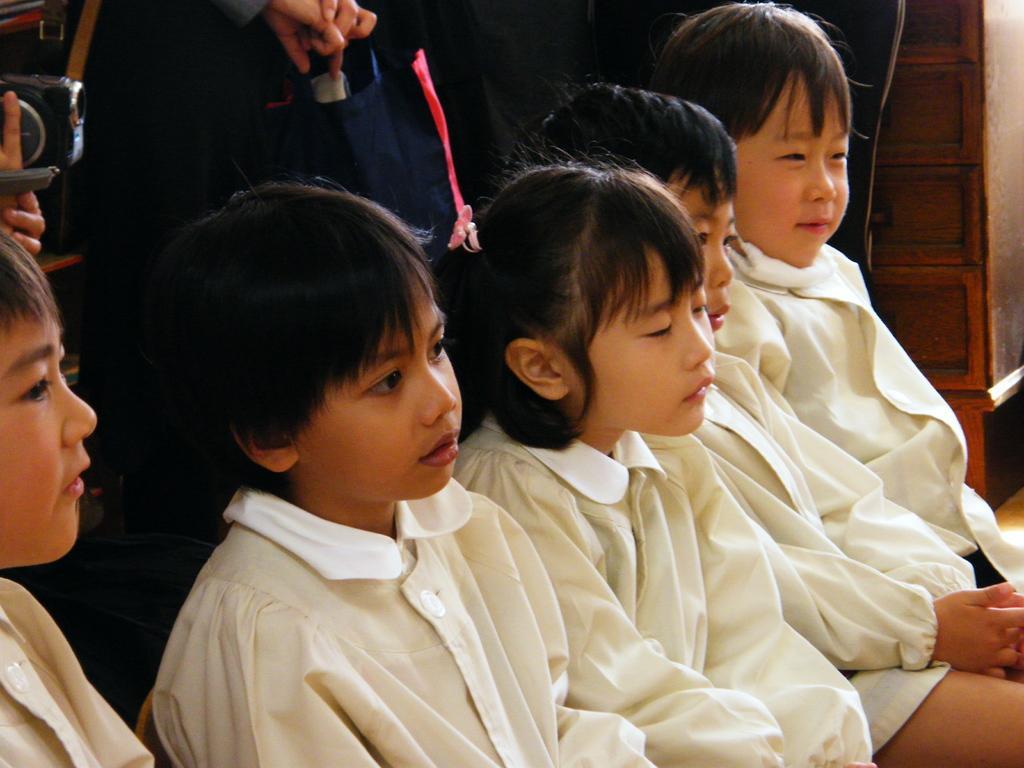How would you summarize this image in a sentence or two? In the foreground of this picture, there are boys and a girl sitting in white dresses. In the background, we can see a person holding camera and a person standing. 